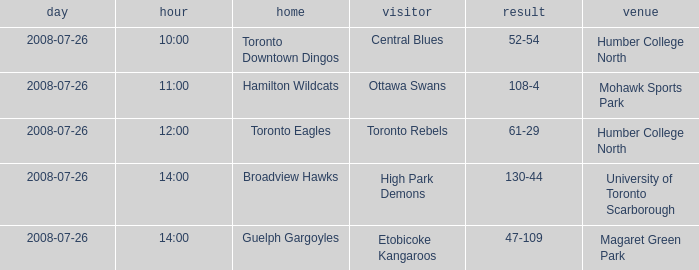Who has the Home Score of 52-54? Toronto Downtown Dingos. 